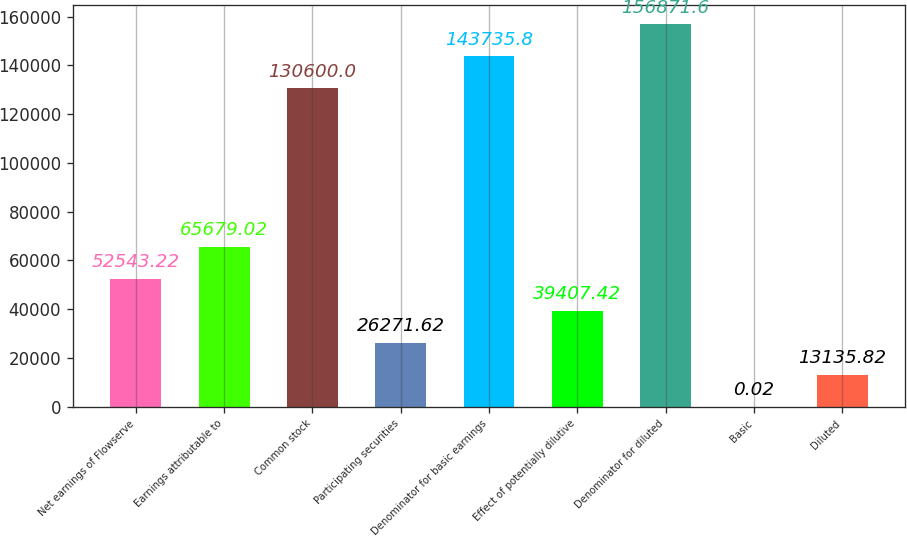Convert chart. <chart><loc_0><loc_0><loc_500><loc_500><bar_chart><fcel>Net earnings of Flowserve<fcel>Earnings attributable to<fcel>Common stock<fcel>Participating securities<fcel>Denominator for basic earnings<fcel>Effect of potentially dilutive<fcel>Denominator for diluted<fcel>Basic<fcel>Diluted<nl><fcel>52543.2<fcel>65679<fcel>130600<fcel>26271.6<fcel>143736<fcel>39407.4<fcel>156872<fcel>0.02<fcel>13135.8<nl></chart> 